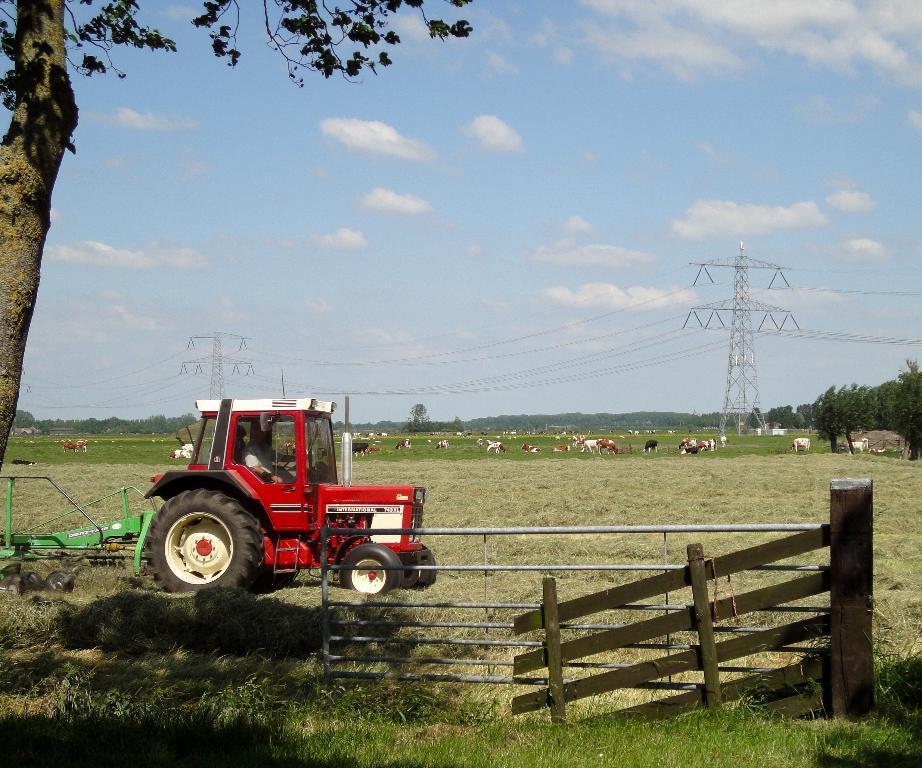Describe this image in one or two sentences. In this picture I can see a vehicle on the grass, there is fence, there are animals, cell towers, cables, trees, and in the background there is sky. 